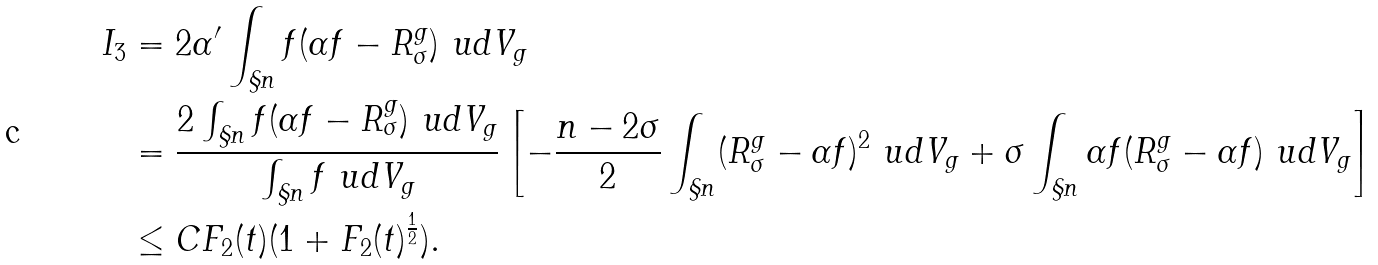<formula> <loc_0><loc_0><loc_500><loc_500>I _ { 3 } & = 2 \alpha ^ { \prime } \int _ { \S n } f ( \alpha f - R _ { \sigma } ^ { g } ) \ u d V _ { g } \\ & = \frac { 2 \int _ { \S n } f ( \alpha f - R _ { \sigma } ^ { g } ) \ u d V _ { g } } { \int _ { \S n } f \ u d V _ { g } } \left [ - \frac { n - 2 \sigma } { 2 } \int _ { \S n } ( R _ { \sigma } ^ { g } - \alpha f ) ^ { 2 } \ u d V _ { g } + \sigma \int _ { \S n } \alpha f ( R _ { \sigma } ^ { g } - \alpha f ) \ u d V _ { g } \right ] \\ & \leq C F _ { 2 } ( t ) ( 1 + F _ { 2 } ( t ) ^ { \frac { 1 } { 2 } } ) .</formula> 